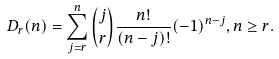Convert formula to latex. <formula><loc_0><loc_0><loc_500><loc_500>D _ { r } ( n ) = \sum _ { j = r } ^ { n } { j \choose r } \frac { n ! } { ( n - j ) ! } ( - 1 ) ^ { n - j } , n \geq r .</formula> 